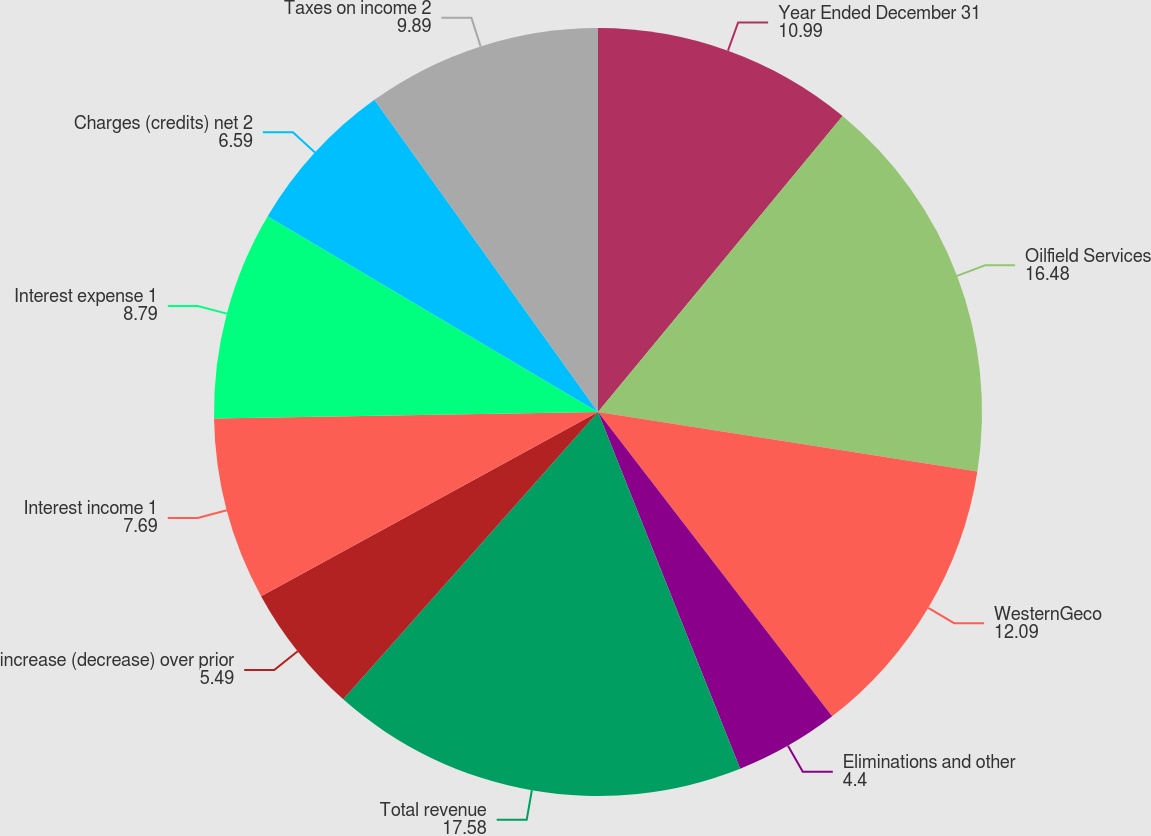Convert chart. <chart><loc_0><loc_0><loc_500><loc_500><pie_chart><fcel>Year Ended December 31<fcel>Oilfield Services<fcel>WesternGeco<fcel>Eliminations and other<fcel>Total revenue<fcel>increase (decrease) over prior<fcel>Interest income 1<fcel>Interest expense 1<fcel>Charges (credits) net 2<fcel>Taxes on income 2<nl><fcel>10.99%<fcel>16.48%<fcel>12.09%<fcel>4.4%<fcel>17.58%<fcel>5.49%<fcel>7.69%<fcel>8.79%<fcel>6.59%<fcel>9.89%<nl></chart> 